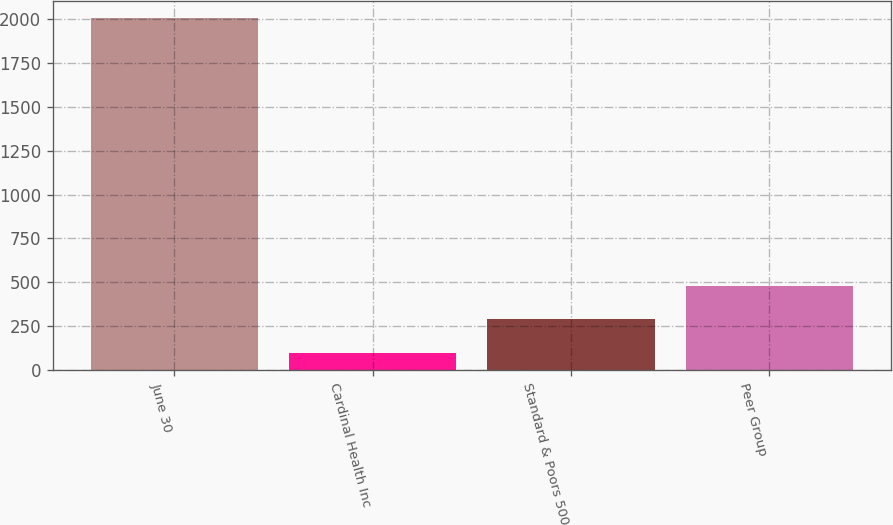Convert chart. <chart><loc_0><loc_0><loc_500><loc_500><bar_chart><fcel>June 30<fcel>Cardinal Health Inc<fcel>Standard & Poors 500<fcel>Peer Group<nl><fcel>2004<fcel>100<fcel>290.4<fcel>480.8<nl></chart> 